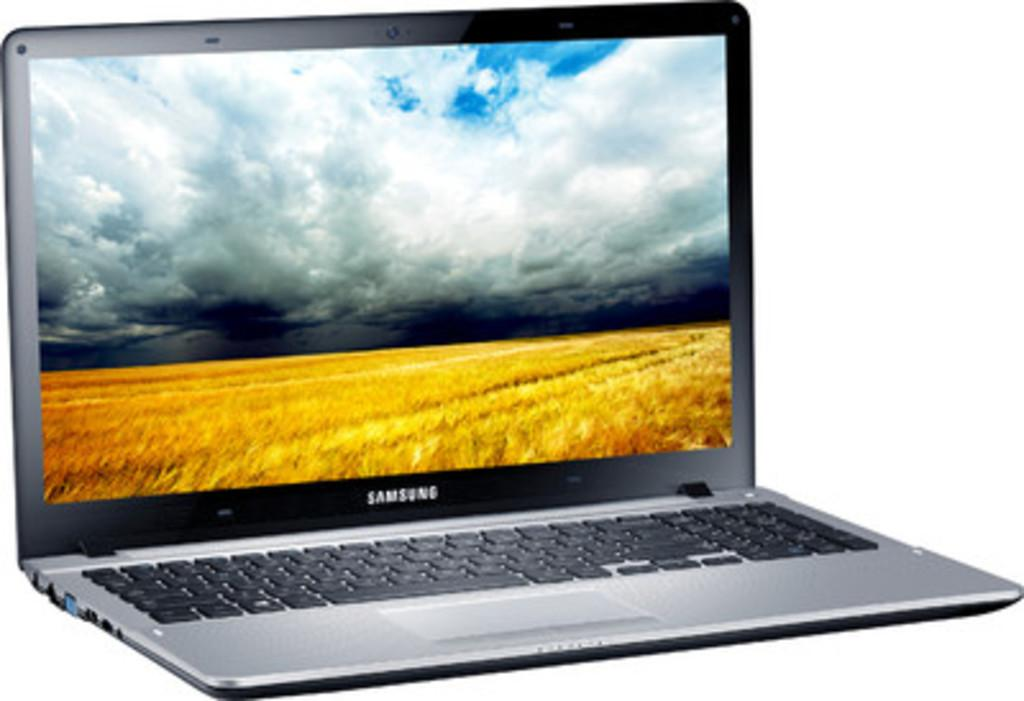<image>
Provide a brief description of the given image. a sansung flat screen laptop with an open field on the screen saver 